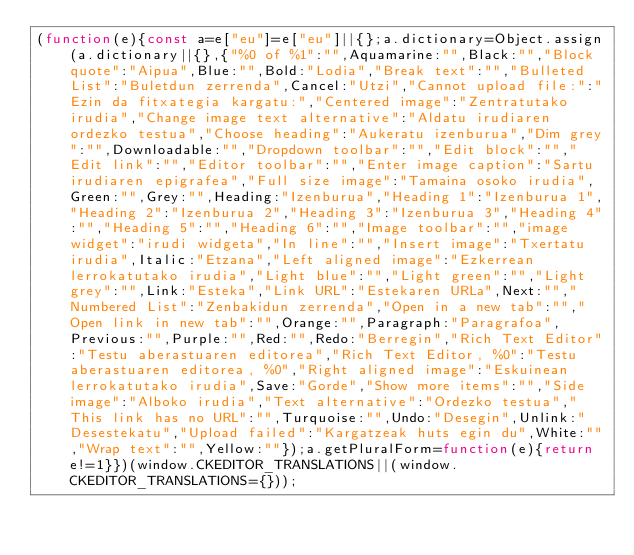Convert code to text. <code><loc_0><loc_0><loc_500><loc_500><_JavaScript_>(function(e){const a=e["eu"]=e["eu"]||{};a.dictionary=Object.assign(a.dictionary||{},{"%0 of %1":"",Aquamarine:"",Black:"","Block quote":"Aipua",Blue:"",Bold:"Lodia","Break text":"","Bulleted List":"Buletdun zerrenda",Cancel:"Utzi","Cannot upload file:":"Ezin da fitxategia kargatu:","Centered image":"Zentratutako irudia","Change image text alternative":"Aldatu irudiaren ordezko testua","Choose heading":"Aukeratu izenburua","Dim grey":"",Downloadable:"","Dropdown toolbar":"","Edit block":"","Edit link":"","Editor toolbar":"","Enter image caption":"Sartu irudiaren epigrafea","Full size image":"Tamaina osoko irudia",Green:"",Grey:"",Heading:"Izenburua","Heading 1":"Izenburua 1","Heading 2":"Izenburua 2","Heading 3":"Izenburua 3","Heading 4":"","Heading 5":"","Heading 6":"","Image toolbar":"","image widget":"irudi widgeta","In line":"","Insert image":"Txertatu irudia",Italic:"Etzana","Left aligned image":"Ezkerrean lerrokatutako irudia","Light blue":"","Light green":"","Light grey":"",Link:"Esteka","Link URL":"Estekaren URLa",Next:"","Numbered List":"Zenbakidun zerrenda","Open in a new tab":"","Open link in new tab":"",Orange:"",Paragraph:"Paragrafoa",Previous:"",Purple:"",Red:"",Redo:"Berregin","Rich Text Editor":"Testu aberastuaren editorea","Rich Text Editor, %0":"Testu aberastuaren editorea, %0","Right aligned image":"Eskuinean lerrokatutako irudia",Save:"Gorde","Show more items":"","Side image":"Alboko irudia","Text alternative":"Ordezko testua","This link has no URL":"",Turquoise:"",Undo:"Desegin",Unlink:"Desestekatu","Upload failed":"Kargatzeak huts egin du",White:"","Wrap text":"",Yellow:""});a.getPluralForm=function(e){return e!=1}})(window.CKEDITOR_TRANSLATIONS||(window.CKEDITOR_TRANSLATIONS={}));</code> 